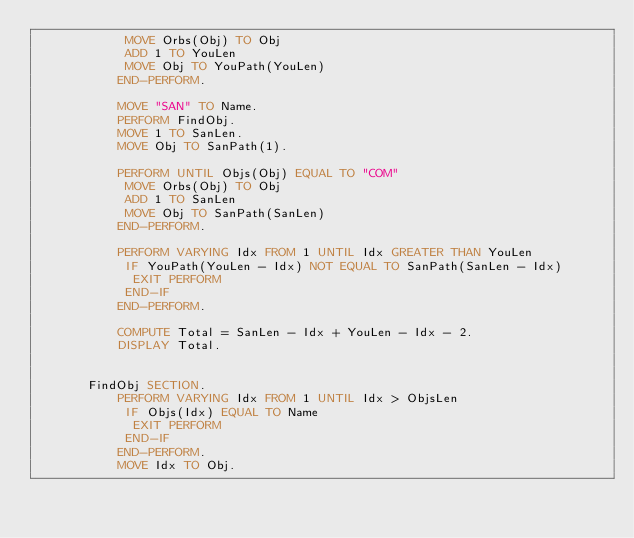Convert code to text. <code><loc_0><loc_0><loc_500><loc_500><_COBOL_>            MOVE Orbs(Obj) TO Obj
            ADD 1 TO YouLen
            MOVE Obj TO YouPath(YouLen)
           END-PERFORM.

           MOVE "SAN" TO Name.
           PERFORM FindObj.
           MOVE 1 TO SanLen.
           MOVE Obj TO SanPath(1).

           PERFORM UNTIL Objs(Obj) EQUAL TO "COM"
            MOVE Orbs(Obj) TO Obj
            ADD 1 TO SanLen
            MOVE Obj TO SanPath(SanLen)
           END-PERFORM.

           PERFORM VARYING Idx FROM 1 UNTIL Idx GREATER THAN YouLen
            IF YouPath(YouLen - Idx) NOT EQUAL TO SanPath(SanLen - Idx)
             EXIT PERFORM
            END-IF
           END-PERFORM.

           COMPUTE Total = SanLen - Idx + YouLen - Idx - 2.
           DISPLAY Total.


       FindObj SECTION.
           PERFORM VARYING Idx FROM 1 UNTIL Idx > ObjsLen
            IF Objs(Idx) EQUAL TO Name
             EXIT PERFORM
            END-IF
           END-PERFORM.
           MOVE Idx TO Obj.
</code> 